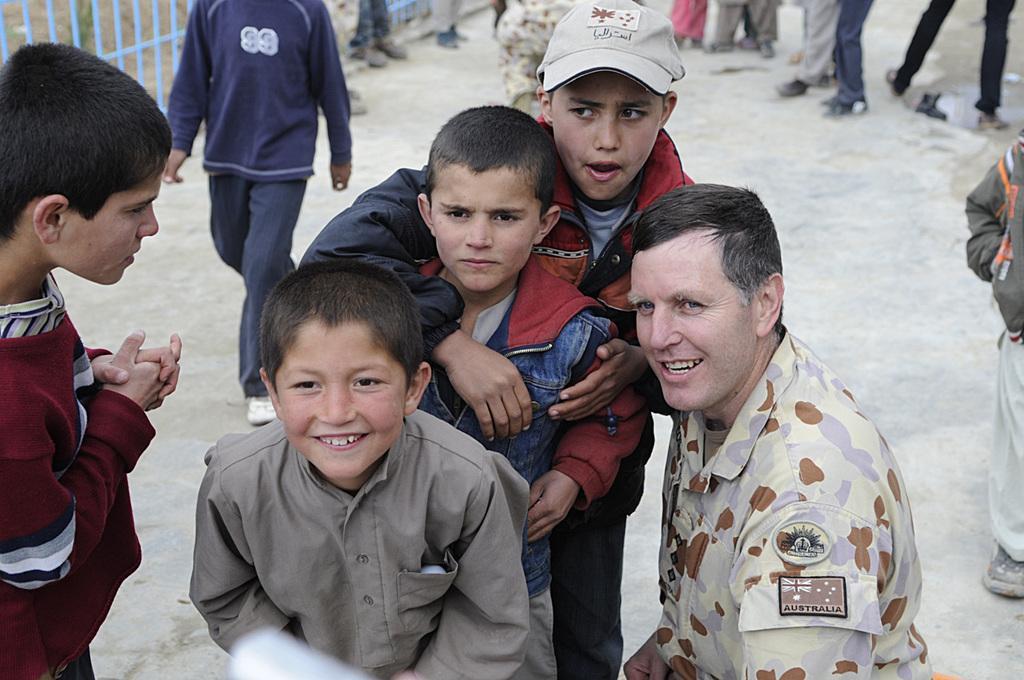In one or two sentences, can you explain what this image depicts? There is a person in a shirt, smiling and kneeling down on the ground. Beside him, there are children standing and smiling on the ground. In the background, there are other persons standing and there is a blue color fencing. 